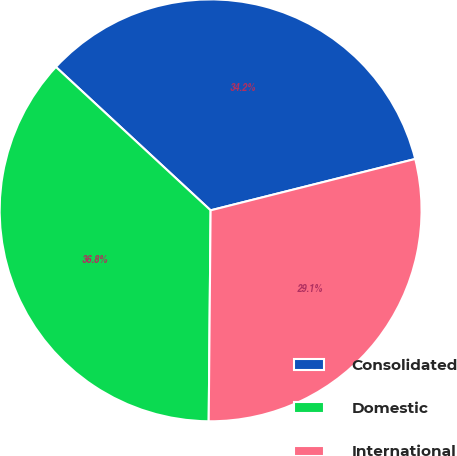Convert chart. <chart><loc_0><loc_0><loc_500><loc_500><pie_chart><fcel>Consolidated<fcel>Domestic<fcel>International<nl><fcel>34.19%<fcel>36.75%<fcel>29.06%<nl></chart> 